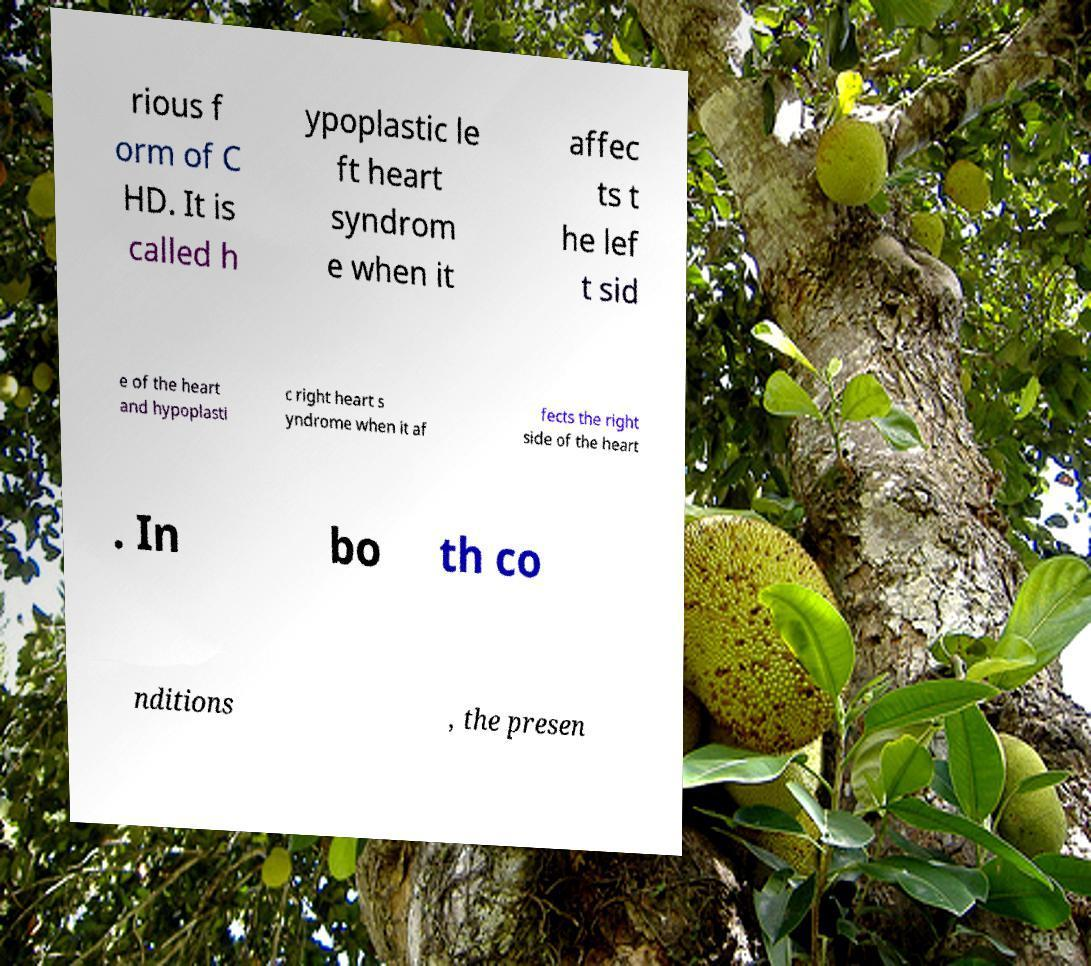I need the written content from this picture converted into text. Can you do that? rious f orm of C HD. It is called h ypoplastic le ft heart syndrom e when it affec ts t he lef t sid e of the heart and hypoplasti c right heart s yndrome when it af fects the right side of the heart . In bo th co nditions , the presen 